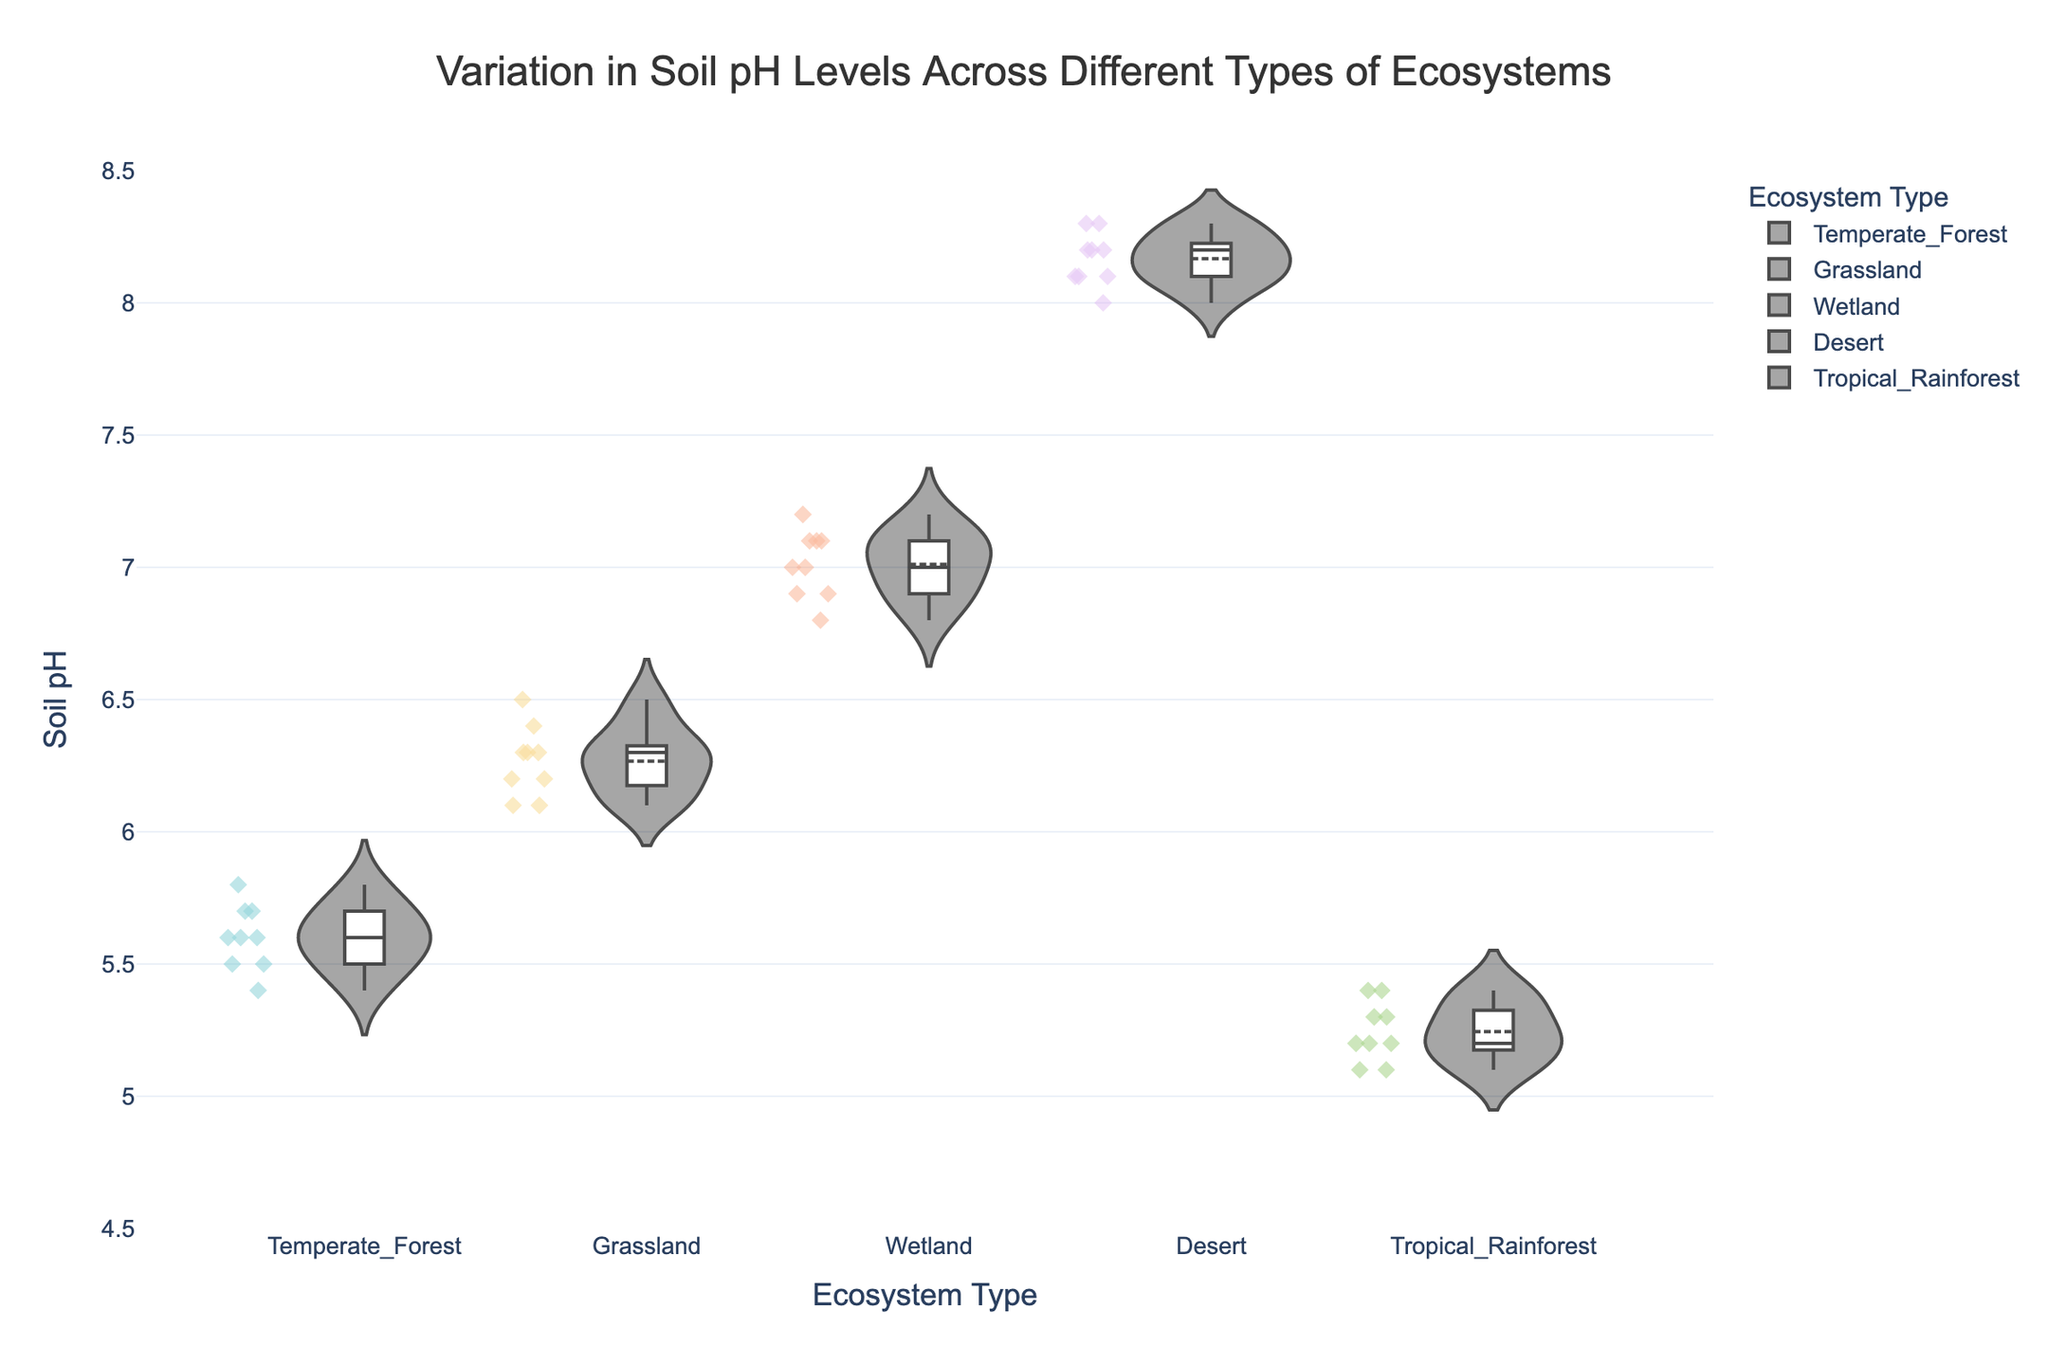How many types of ecosystems are represented in the violin plot? The title of the plot indicates "Different Types of Ecosystems," and the x-axis labels show the specific categories. Counting these labels gives the number of types.
Answer: 5 Which ecosystem type has the highest average soil pH value? The median line in each violin plot indicates the central tendency. The desert ecosystem's median line is at the highest position on the y-axis.
Answer: Desert What is the range of soil pH values in the Grassland ecosystem? The furthest points within the box in the grassland violin plot represent the range of values. The lowest is 6.1, and the highest is 6.5.
Answer: 6.1 to 6.5 How does the variability in soil pH for Wetlands compare to that of Temperate Forests? The width of the violin plot indicates variability. The Wetland plot is wider than the Temperate Forest plot, indicating more variability.
Answer: Wetlands have more variability Which two ecosystems have the closest median soil pH values? Observing the medians of each violin plot, the Temperate Forest and Tropical Rainforest plots have median lines closest to each other.
Answer: Temperate Forest and Tropical Rainforest Are there any ecosystems where the distribution of soil pH values is relatively symmetrical? A symmetrical violin plot looks like a mirror image on either side of the center line. Both the Desert and Temperate Forest plots show relatively symmetrical shapes.
Answer: Desert, Temperate Forest In which ecosystem is the smallest soil pH value observed, and what is that value? The Tropical Rainforest plot has the smallest value at the bottom of the violins, which touches the 5.1 mark.
Answer: Tropical Rainforest, 5.1 Which ecosystem shows the least variability in soil pH values? The ecosystem with the narrowest violin plot indicates less variability. The Tropical Rainforest has the narrowest plot width.
Answer: Tropical Rainforest 